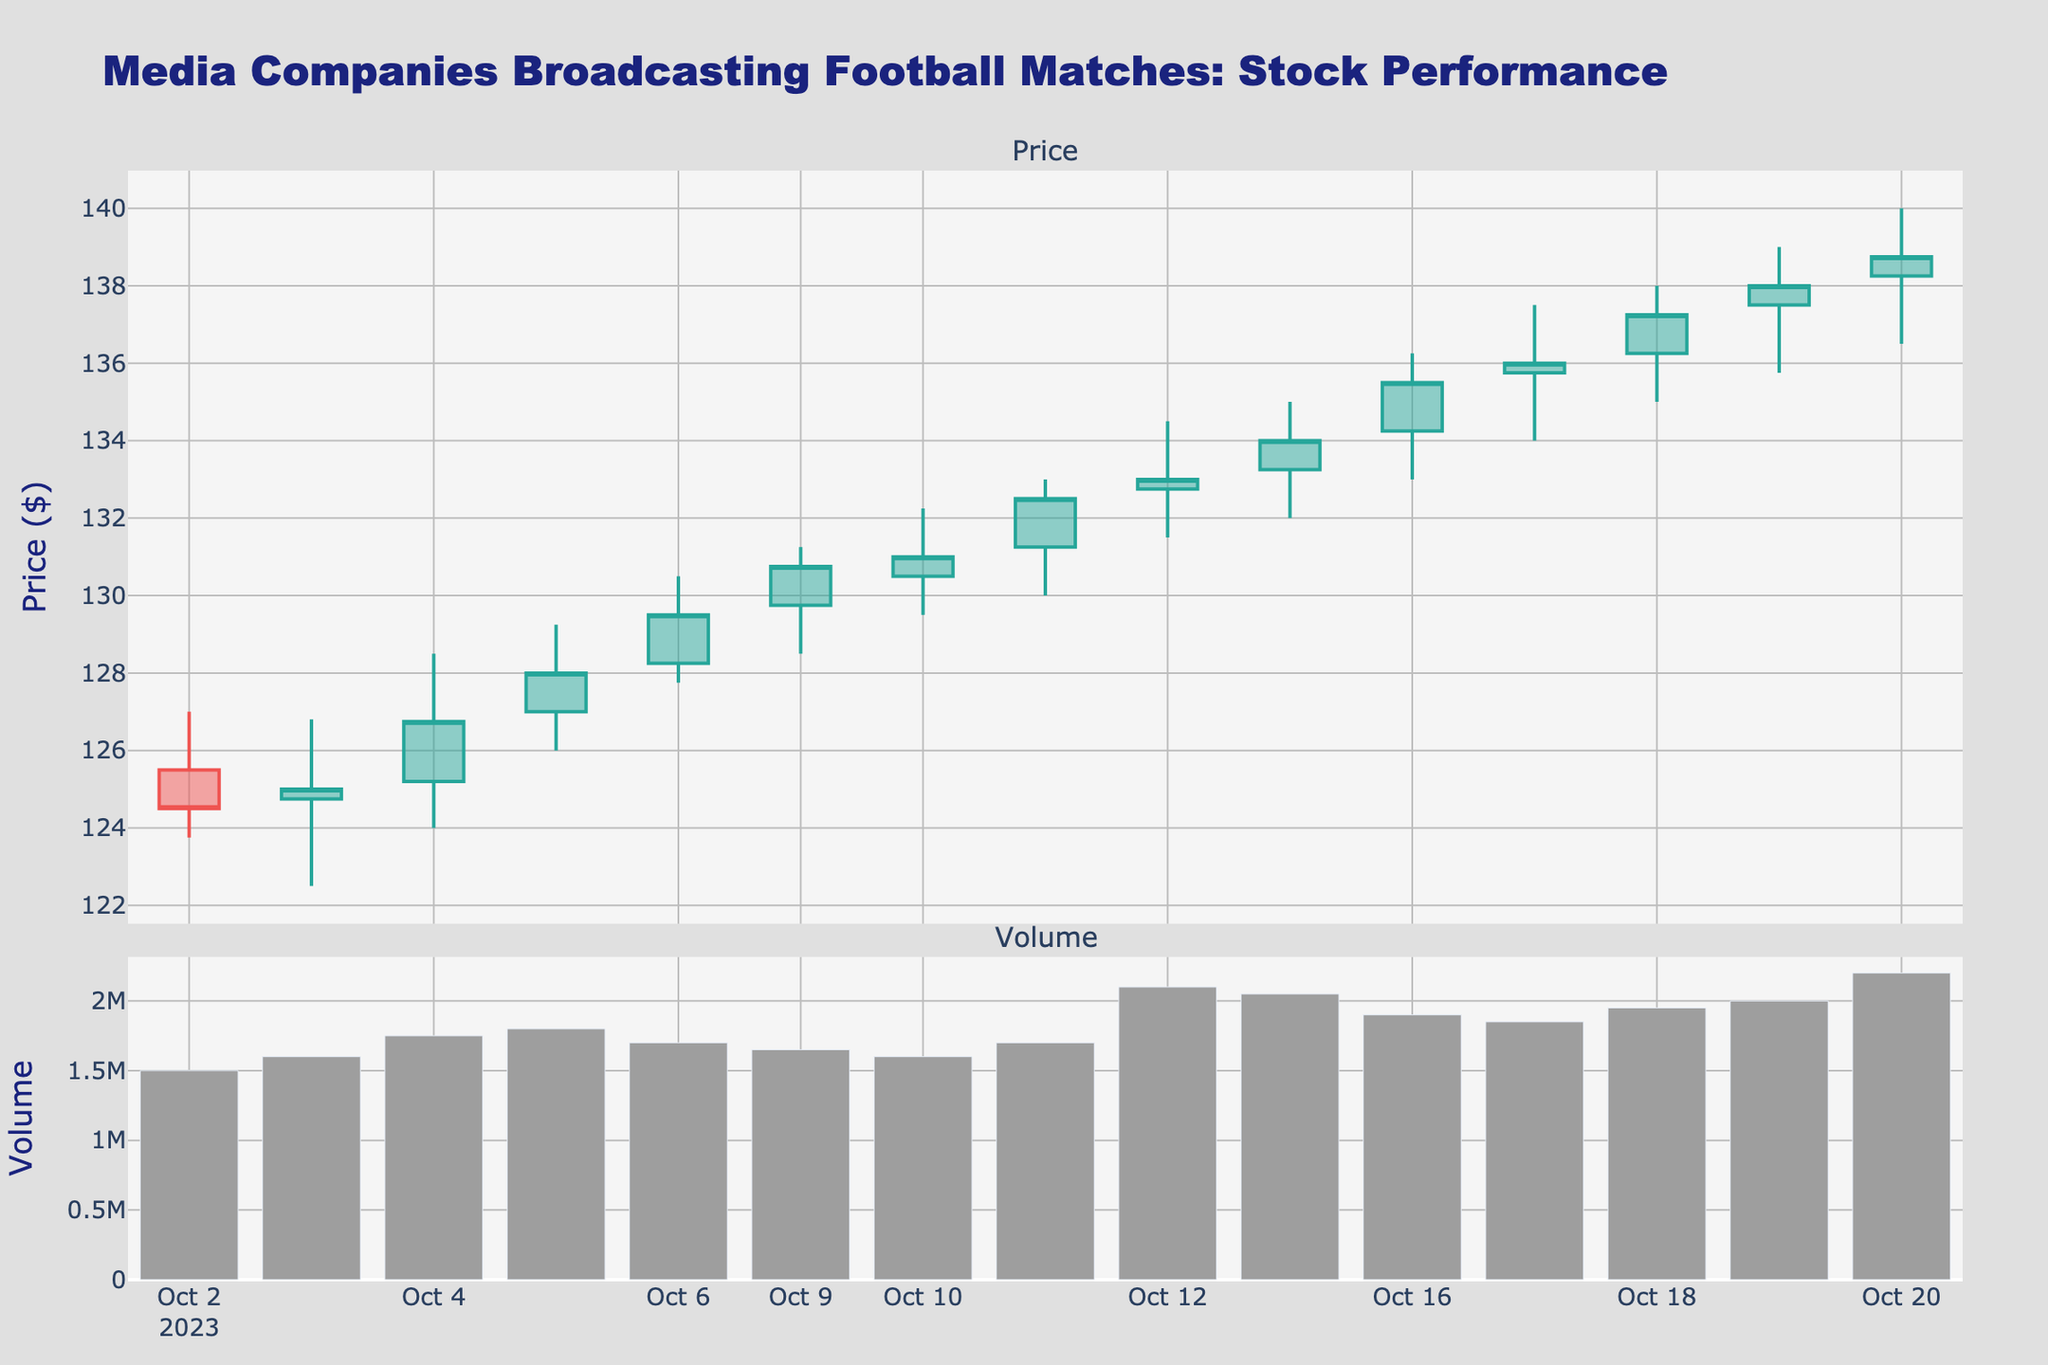What's the title of the plot? The title is displayed at the top of the plot, indicating the subject of the data being visualized.
Answer: Media Companies Broadcasting Football Matches: Stock Performance What is the color of the increasing price candle? The increasing price candle is represented by the line color showing a rise in the stock price, which can be identified by looking for green-colored bars.
Answer: Green How many data points are visible in the plot? Counting the number of candlesticks will give the number of trading days represented in the plot. Each candlestick represents one day's worth of data. There are 15 candlesticks, one for each day from 2023-10-02 to 2023-10-20.
Answer: 15 What is the lowest price recorded in the data? Spotting the lowest point in the figure, which is the bottom end of the lowest candlestick, identifies the lowest price. On 2023-10-03, the price dropped to $122.50.
Answer: $122.50 What was the closing price on 2023-10-10? The closing price for 2023-10-10 is the point at which the candlestick line ends for that particular day. Checking the candlestick for 2023-10-10, the closing price is observed to be $131.00.
Answer: $131.00 What day had the highest trading volume, and what was the volume? To find the highest trading volume day, look at the bar chart below the candlestick plot. The tallest bar represents the highest volume. The highest volume occurred on 2023-10-12 with a volume of 2,100,000.
Answer: 2023-10-12, 2,100,000 How does the closing price on 2023-10-13 compare to the opening price on 2023-10-09? To compare these prices, find the closing price on 2023-10-13 and the opening price on 2023-10-09, then observe if the latter is higher or lower. The closing price on 2023-10-13 is $134.00, and the opening price on 2023-10-09 is $129.75.
Answer: The closing price on 2023-10-13 is higher What is the average closing price for the week starting 2023-10-16? To find the average closing price: add the closing prices from each day of the week and divide by the number of days (5). The closing prices are: 135.50, 136.00, 137.25, 138.00, 138.75. The sum of these prices is 685.50, and there are 5 days. So the average is 685.50 / 5.
Answer: $137.10 How does the closing price trend from 2023-10-02 to 2023-10-06? Checking the closing prices from the start to the end of this week reveals a pattern or trend. The closing prices for 2023-10-02 to 2023-10-06 are: 124.50, 125.00, 126.75, 128.00, and 129.50, respectively. It’s a rising trend.
Answer: Increasing trend Are there more increasing or decreasing candlesticks in the plot? Compare the number of green (increasing) and red (decreasing) candlesticks in the plot. Count the increasing ones and the decreasing ones to determine which is greater. There are 10 increasing and 5 decreasing candlesticks.
Answer: More increasing candlesticks 